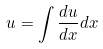Convert formula to latex. <formula><loc_0><loc_0><loc_500><loc_500>u = \int \frac { d u } { d x } d x</formula> 